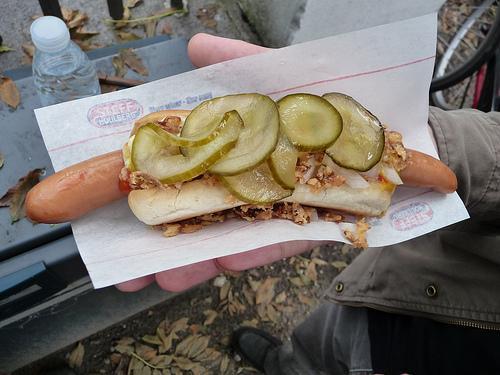How many hotdogs are there?
Give a very brief answer. 1. 